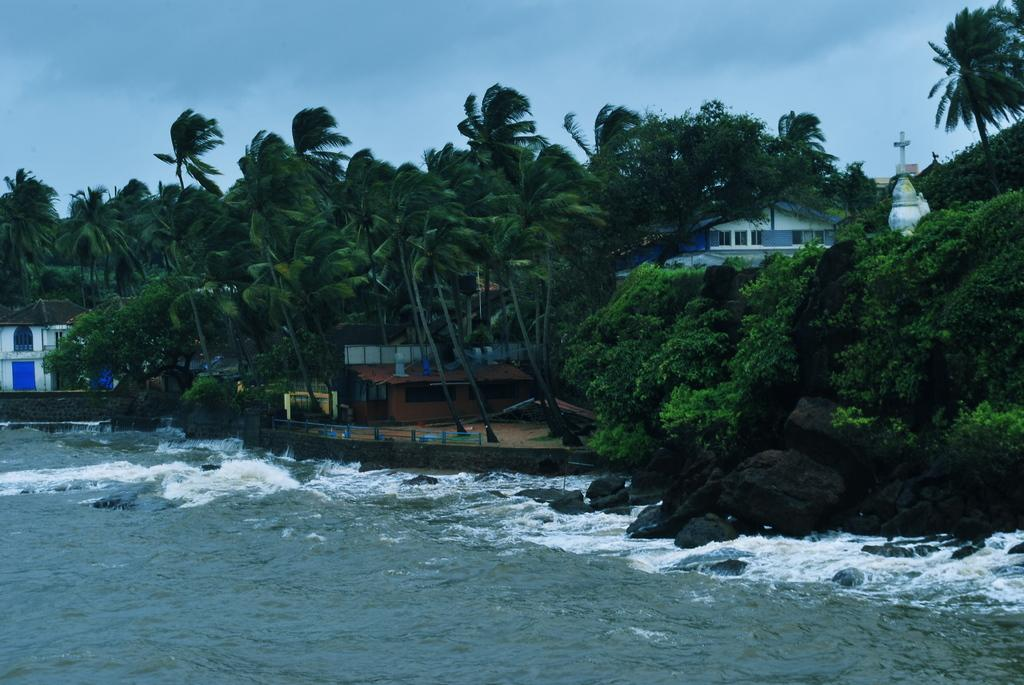What type of natural elements can be seen in the image? There are rocks and trees in the image. What man-made structures are visible in the image? There are buildings in the image. What other objects can be seen in the image besides rocks, trees, and buildings? There are other objects in the image. What is visible at the top of the image? The sky is visible at the top of the image. What is present at the bottom of the image? Water is present at the bottom of the image. What is the cent of gravity in the image? The concept of a cent of gravity is not applicable to an image, as it is a physical property of objects and not a visual element. What activity is taking place in the image? The image does not depict any specific activity; it shows a scene with rocks, trees, buildings, other objects, sky, and water. 